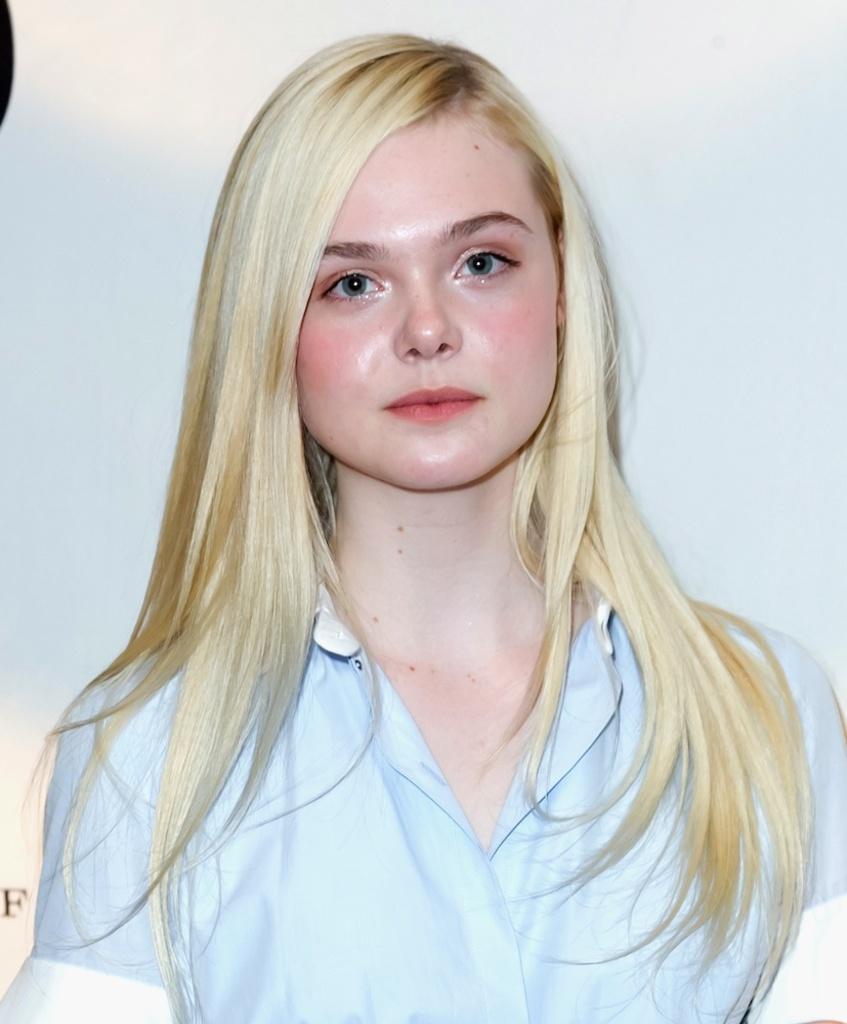What is the main subject of the image? There is a girl in the image. Where is the girl positioned in the image? The girl is standing in the center of the image. What is the opinion of the turkey in the image? There is no turkey present in the image, so it is not possible to determine its opinion. 